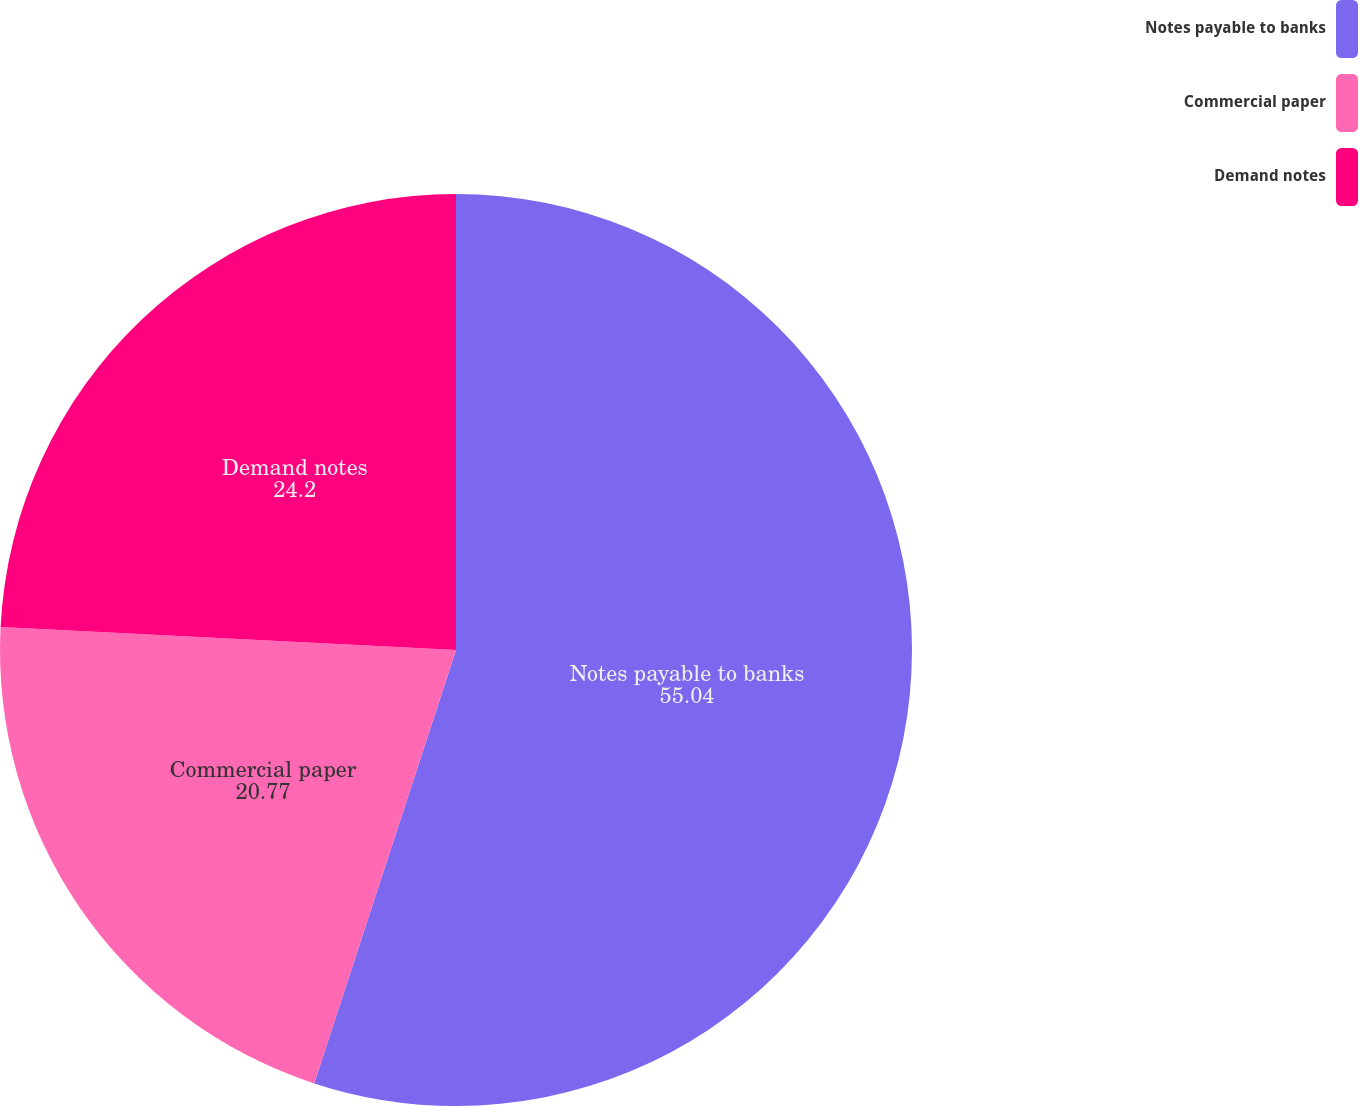Convert chart to OTSL. <chart><loc_0><loc_0><loc_500><loc_500><pie_chart><fcel>Notes payable to banks<fcel>Commercial paper<fcel>Demand notes<nl><fcel>55.04%<fcel>20.77%<fcel>24.2%<nl></chart> 